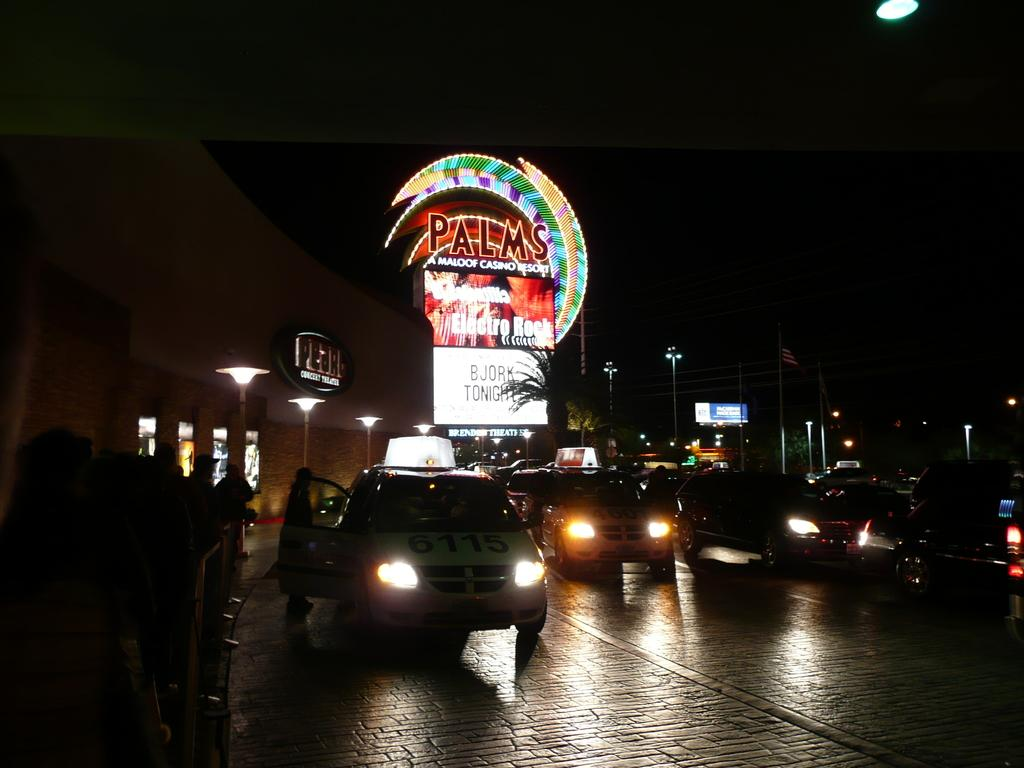Provide a one-sentence caption for the provided image. Bjork is playing tonight at the Palms casino and resort. 